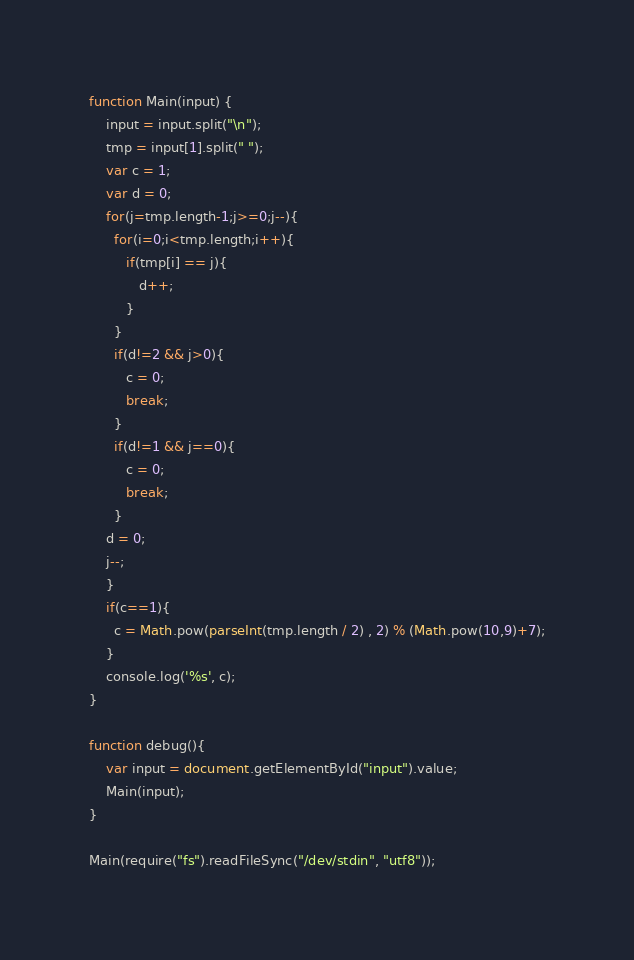<code> <loc_0><loc_0><loc_500><loc_500><_JavaScript_>function Main(input) {
    input = input.split("\n");
    tmp = input[1].split(" ");
    var c = 1;
    var d = 0;
    for(j=tmp.length-1;j>=0;j--){
      for(i=0;i<tmp.length;i++){
         if(tmp[i] == j){
            d++;
         }
      }
      if(d!=2 && j>0){
         c = 0;
         break;
      }
      if(d!=1 && j==0){
         c = 0;
         break;
      }
    d = 0;
    j--;
    }
    if(c==1){
      c = Math.pow(parseInt(tmp.length / 2) , 2) % (Math.pow(10,9)+7);
    }
    console.log('%s', c);
}

function debug(){
	var input = document.getElementById("input").value;
	Main(input);
}

Main(require("fs").readFileSync("/dev/stdin", "utf8"));</code> 